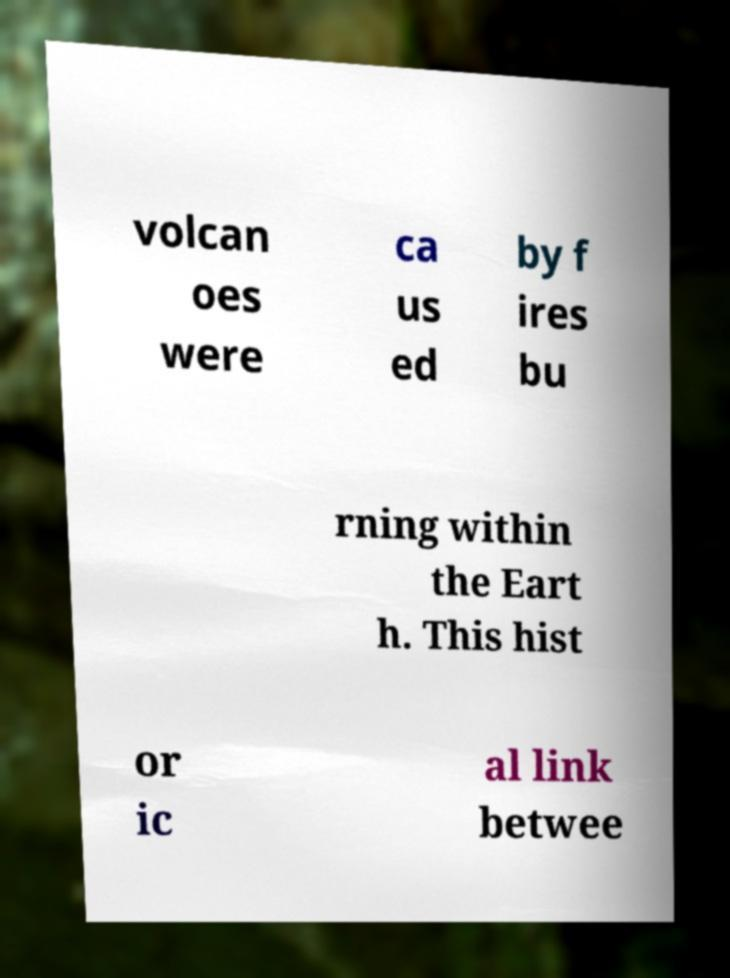Please read and relay the text visible in this image. What does it say? volcan oes were ca us ed by f ires bu rning within the Eart h. This hist or ic al link betwee 